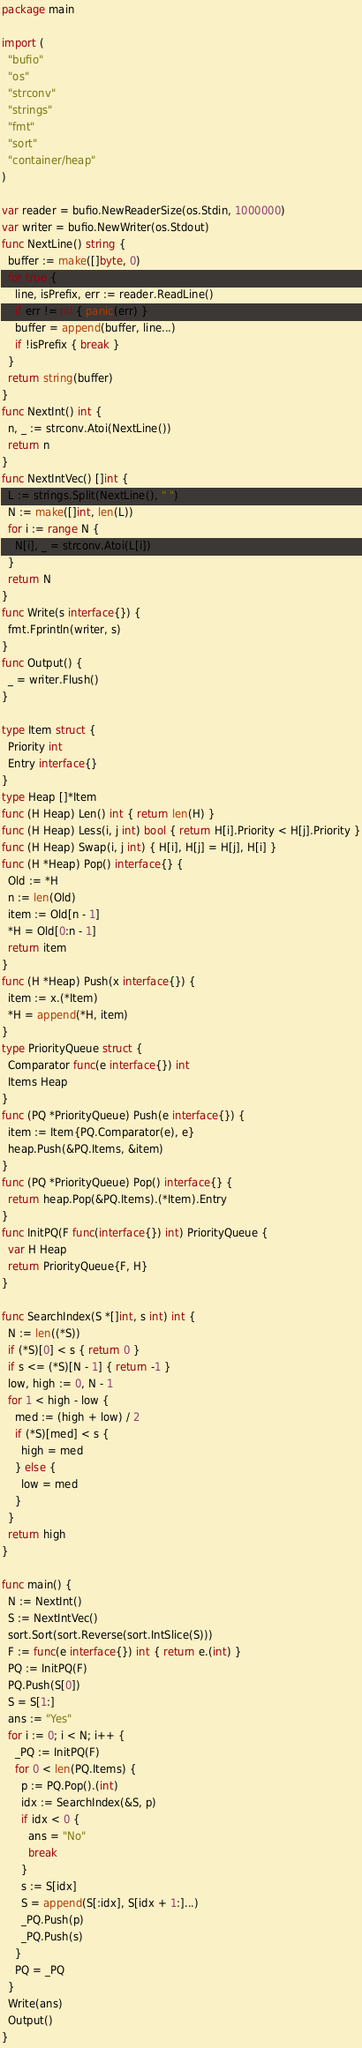<code> <loc_0><loc_0><loc_500><loc_500><_Go_>package main

import (
  "bufio"
  "os"
  "strconv"
  "strings"
  "fmt"
  "sort"
  "container/heap"
)

var reader = bufio.NewReaderSize(os.Stdin, 1000000)
var writer = bufio.NewWriter(os.Stdout)
func NextLine() string {
  buffer := make([]byte, 0)
  for true {
    line, isPrefix, err := reader.ReadLine()
    if err != nil { panic(err) }
    buffer = append(buffer, line...)
    if !isPrefix { break }
  }
  return string(buffer)
}
func NextInt() int {
  n, _ := strconv.Atoi(NextLine())
  return n
}
func NextIntVec() []int {
  L := strings.Split(NextLine(), " ")
  N := make([]int, len(L))
  for i := range N {
    N[i], _ = strconv.Atoi(L[i])
  }
  return N
}
func Write(s interface{}) {
  fmt.Fprintln(writer, s)
}
func Output() {
  _ = writer.Flush()
}

type Item struct {
  Priority int
  Entry interface{}
}
type Heap []*Item
func (H Heap) Len() int { return len(H) }
func (H Heap) Less(i, j int) bool { return H[i].Priority < H[j].Priority }
func (H Heap) Swap(i, j int) { H[i], H[j] = H[j], H[i] }
func (H *Heap) Pop() interface{} {
  Old := *H
  n := len(Old)
  item := Old[n - 1]
  *H = Old[0:n - 1]
  return item
}
func (H *Heap) Push(x interface{}) {
  item := x.(*Item)
  *H = append(*H, item)
}
type PriorityQueue struct {
  Comparator func(e interface{}) int
  Items Heap
}
func (PQ *PriorityQueue) Push(e interface{}) {
  item := Item{PQ.Comparator(e), e}
  heap.Push(&PQ.Items, &item)
}
func (PQ *PriorityQueue) Pop() interface{} {
  return heap.Pop(&PQ.Items).(*Item).Entry
}
func InitPQ(F func(interface{}) int) PriorityQueue {
  var H Heap
  return PriorityQueue{F, H}
}

func SearchIndex(S *[]int, s int) int {
  N := len((*S))
  if (*S)[0] < s { return 0 }
  if s <= (*S)[N - 1] { return -1 }
  low, high := 0, N - 1
  for 1 < high - low {
    med := (high + low) / 2
    if (*S)[med] < s {
      high = med
    } else {
      low = med
    }
  }
  return high
}

func main() {
  N := NextInt()
  S := NextIntVec()
  sort.Sort(sort.Reverse(sort.IntSlice(S)))
  F := func(e interface{}) int { return e.(int) }
  PQ := InitPQ(F)
  PQ.Push(S[0])
  S = S[1:]
  ans := "Yes"
  for i := 0; i < N; i++ {
    _PQ := InitPQ(F)
    for 0 < len(PQ.Items) {
      p := PQ.Pop().(int)
      idx := SearchIndex(&S, p)
      if idx < 0 {
        ans = "No"
        break
      }
      s := S[idx]
      S = append(S[:idx], S[idx + 1:]...)
      _PQ.Push(p)
      _PQ.Push(s)
    }
    PQ = _PQ
  }
  Write(ans)
  Output()
}</code> 